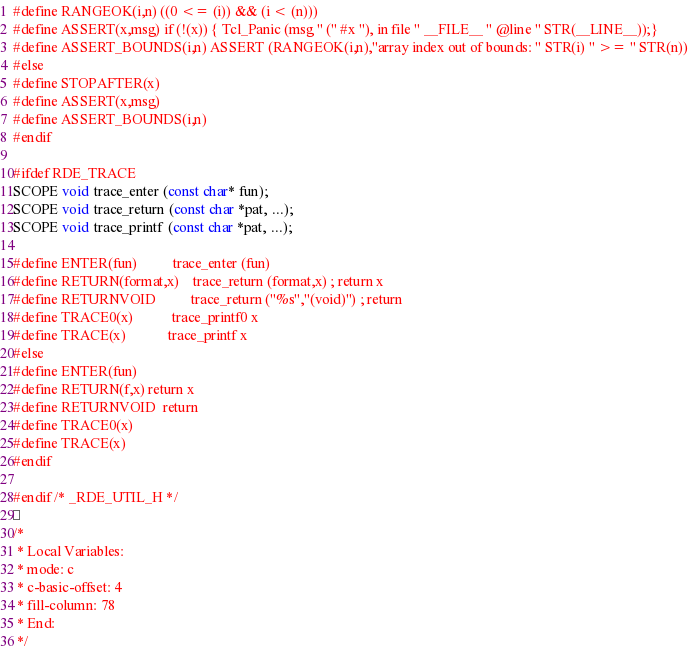<code> <loc_0><loc_0><loc_500><loc_500><_C_>#define RANGEOK(i,n) ((0 <= (i)) && (i < (n)))
#define ASSERT(x,msg) if (!(x)) { Tcl_Panic (msg " (" #x "), in file " __FILE__ " @line " STR(__LINE__));}
#define ASSERT_BOUNDS(i,n) ASSERT (RANGEOK(i,n),"array index out of bounds: " STR(i) " >= " STR(n))
#else
#define STOPAFTER(x)
#define ASSERT(x,msg)
#define ASSERT_BOUNDS(i,n)
#endif

#ifdef RDE_TRACE
SCOPE void trace_enter (const char* fun);
SCOPE void trace_return (const char *pat, ...);
SCOPE void trace_printf (const char *pat, ...);

#define ENTER(fun)          trace_enter (fun)
#define RETURN(format,x)    trace_return (format,x) ; return x
#define RETURNVOID          trace_return ("%s","(void)") ; return
#define TRACE0(x)           trace_printf0 x
#define TRACE(x)            trace_printf x
#else
#define ENTER(fun)
#define RETURN(f,x) return x
#define RETURNVOID  return
#define TRACE0(x)
#define TRACE(x)
#endif

#endif /* _RDE_UTIL_H */

/*
 * Local Variables:
 * mode: c
 * c-basic-offset: 4
 * fill-column: 78
 * End:
 */
</code> 